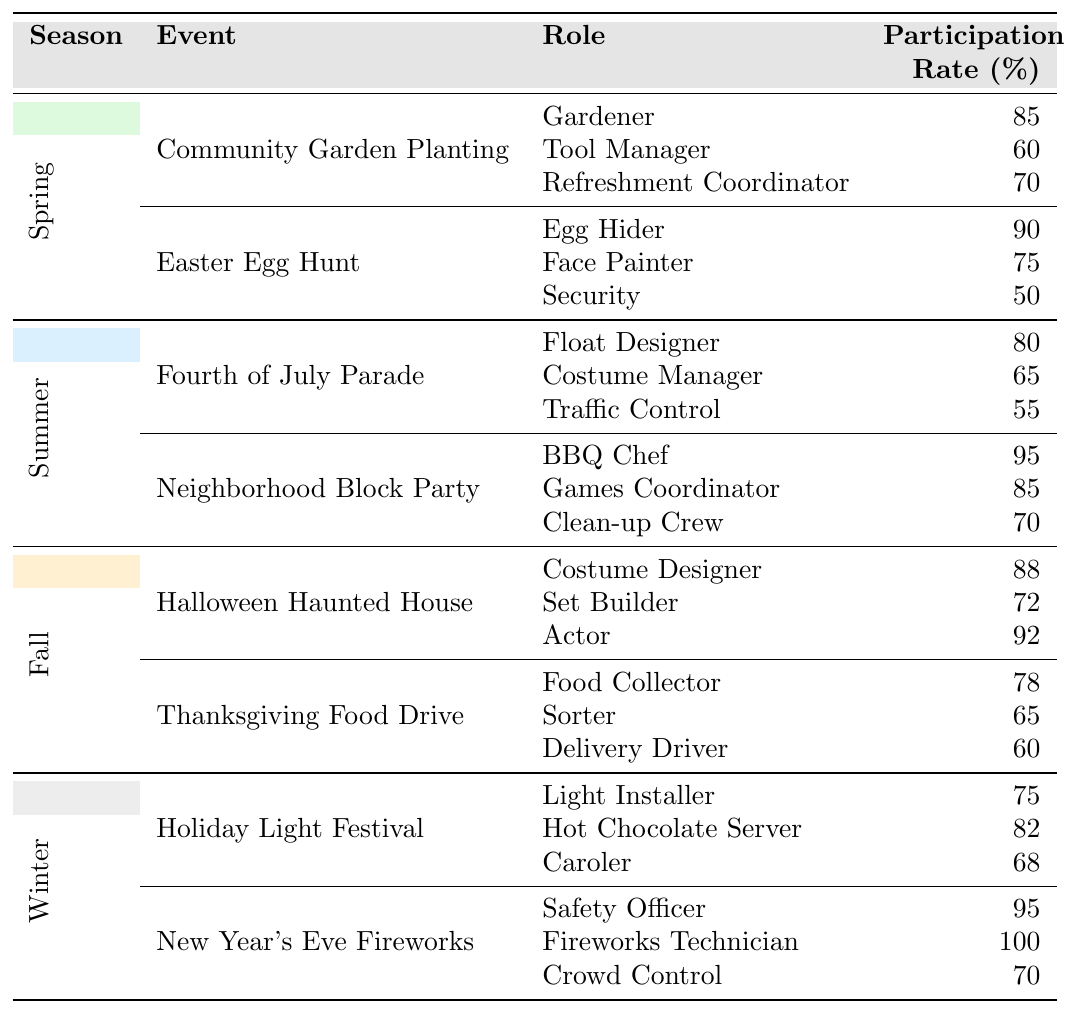What is the role with the highest participation rate in the Winter season? In the Winter section, the roles listed are Light Installer, Hot Chocolate Server, and Caroler. The highest participation rate among these is for the Fireworks Technician at 100%.
Answer: Fireworks Technician Which event has the lowest participation rate in Spring? The Spring section shows the events: Community Garden Planting and Easter Egg Hunt. The role with the lowest participation rate is Security at 50% in the Easter Egg Hunt event.
Answer: Security What are the average participation rates for roles in the Summer events? The Summer events have the following participation rates: Fourth of July Parade (80, 65, 55) and Neighborhood Block Party (95, 85, 70). The average is calculated as follows: (80 + 65 + 55 + 95 + 85 + 70) / 6 = 70.
Answer: 70 Is the participation rate for the BBQ Chef higher than that of the Egg Hider? The participation rate for the BBQ Chef during the Neighborhood Block Party is 95%, and for the Egg Hider during the Easter Egg Hunt, it is 90%. Since 95% is greater than 90%, the statement is true.
Answer: Yes What is the total participation rate for roles in the Fall events combined? In the Fall section, the roles and their rates are: Costume Designer (88), Set Builder (72), Actor (92), Food Collector (78), Sorter (65), Delivery Driver (60). Totaling these gives: 88 + 72 + 92 + 78 + 65 + 60 = 455.
Answer: 455 Which season has the highest overall participation rate for the role of Coordinator? The term "Coordinator" applies to the roles of Refreshment Coordinator in Spring, Games Coordinator in Summer, and Delivery Driver in Fall. Refreshment Coordinator participation is 70%, Games Coordinator is 85%, and Delivery Driver is 60%. The highest participation is from the Summer's Games Coordinator.
Answer: Summer What is the difference in participation rates between the Egg Hider and the Float Designer? The Egg Hider has a participation rate of 90%, and the Float Designer has a participation rate of 80%. Therefore, the difference is 90 - 80 = 10%.
Answer: 10% Which role has a participation rate of 100% and in which event and season does it occur? The role with a participation rate of 100% is Fireworks Technician, which occurs during the New Year's Eve Fireworks event in the Winter season.
Answer: Fireworks Technician in New Year's Eve Fireworks Are there any roles in the Spring season with a participation rate below 60%? The participation rates for Spring roles include Gardener (85), Tool Manager (60), and Refreshment Coordinator (70) in Community Garden Planting, and Egg Hider (90), Face Painter (75), and Security (50) in Easter Egg Hunt. Security is below 60%, making the statement true.
Answer: Yes Which event in Fall has the highest participation rate for any role? In the Fall season, the role with the highest participation rate is Actor, which has a participation rate of 92% during the Halloween Haunted House event.
Answer: Halloween Haunted House 